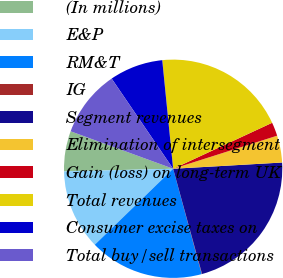Convert chart. <chart><loc_0><loc_0><loc_500><loc_500><pie_chart><fcel>(In millions)<fcel>E&P<fcel>RM&T<fcel>IG<fcel>Segment revenues<fcel>Elimination of intersegment<fcel>Gain (loss) on long-term UK<fcel>Total revenues<fcel>Consumer excise taxes on<fcel>Total buy/sell transactions<nl><fcel>5.96%<fcel>11.87%<fcel>16.96%<fcel>0.05%<fcel>21.64%<fcel>3.99%<fcel>2.02%<fcel>19.67%<fcel>7.93%<fcel>9.9%<nl></chart> 